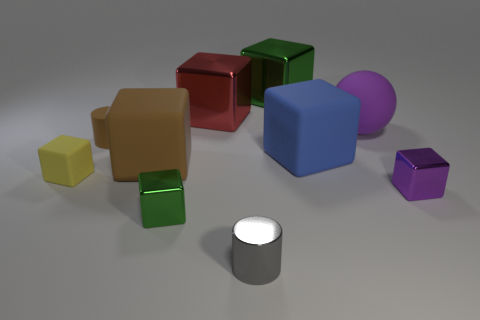Subtract all large brown cubes. How many cubes are left? 6 Subtract all brown cylinders. How many cylinders are left? 1 Subtract 1 blocks. How many blocks are left? 6 Subtract all cylinders. How many objects are left? 8 Subtract all yellow rubber things. Subtract all big purple balls. How many objects are left? 8 Add 5 tiny cylinders. How many tiny cylinders are left? 7 Add 3 tiny gray metallic balls. How many tiny gray metallic balls exist? 3 Subtract 0 cyan cylinders. How many objects are left? 10 Subtract all gray spheres. Subtract all purple cylinders. How many spheres are left? 1 Subtract all cyan cylinders. How many purple cubes are left? 1 